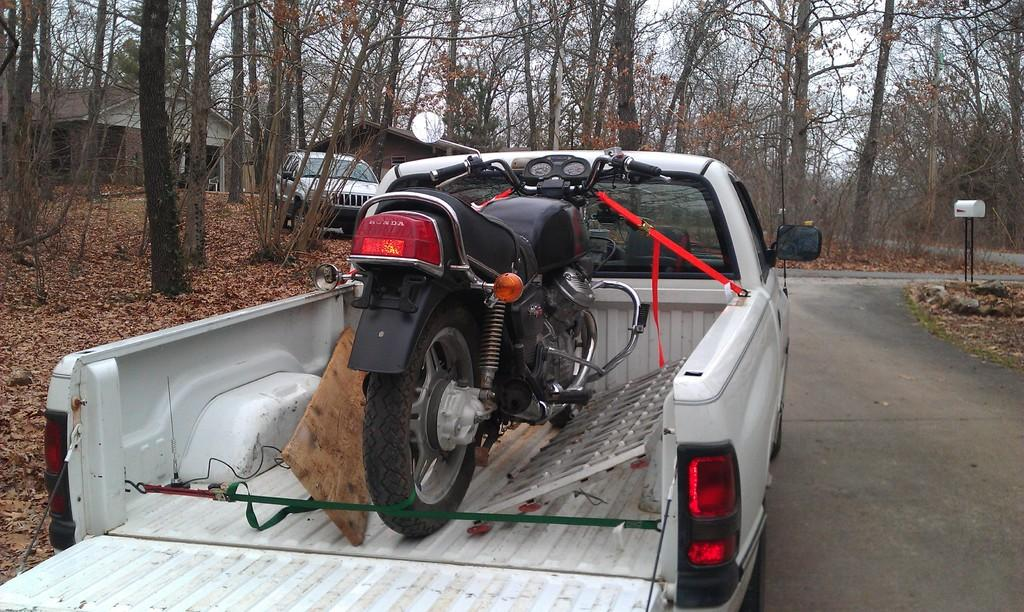What is the main subject of the image? The main subject of the image is a truck. What is on the truck? A vehicle is on the truck. What can be seen in the background of the image? There are tall trees around the road in the image. What is on the left side of the image? There is another vehicle on the left side of the image. What structures are visible behind the left vehicle? There are two houses behind the left vehicle. What type of copper theory can be observed in the image? There is no copper or theory present in the image; it features a truck with a vehicle on it, surrounded by tall trees and other vehicles. Is there a chain connecting the two houses in the image? There is no chain connecting the two houses in the image; they are simply visible in the background behind the left vehicle. 